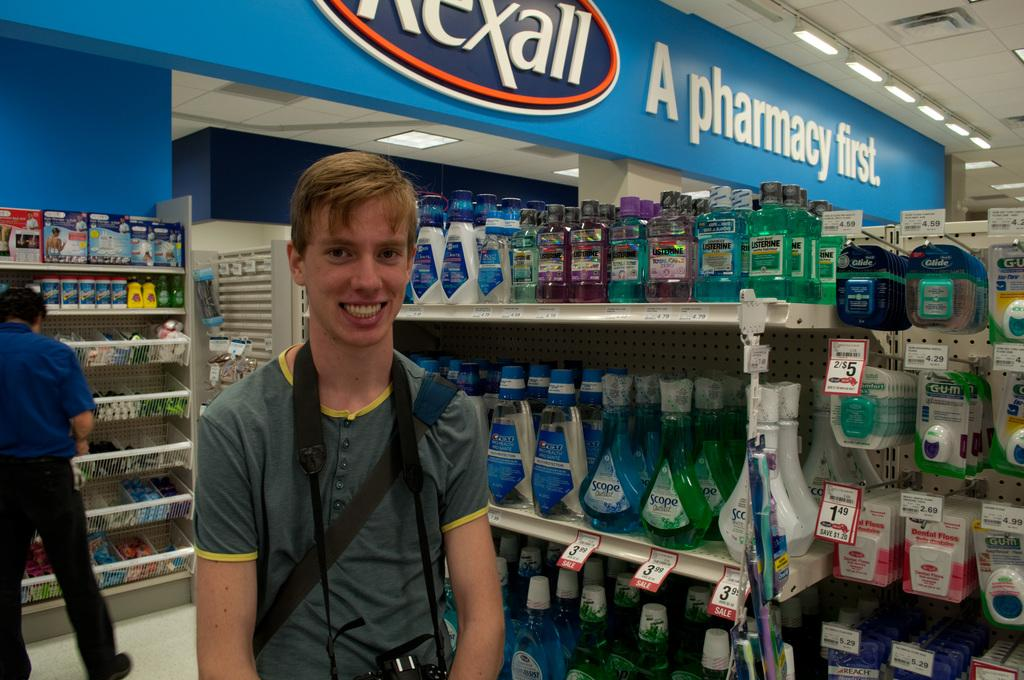Provide a one-sentence caption for the provided image. A blonde man is smiling in front of a blue pharmacy. 